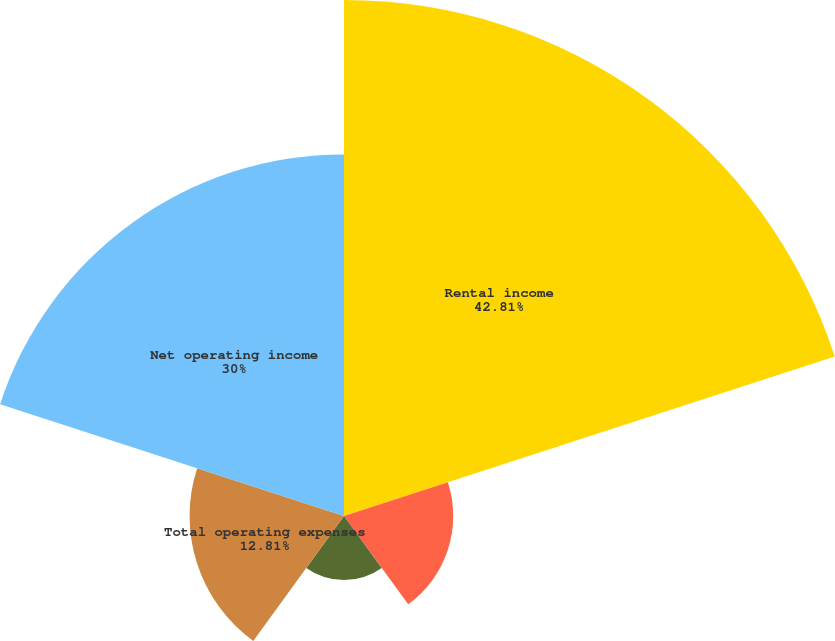Convert chart to OTSL. <chart><loc_0><loc_0><loc_500><loc_500><pie_chart><fcel>Rental income<fcel>Property and maintenance<fcel>Real estate taxes and<fcel>Total operating expenses<fcel>Net operating income<nl><fcel>42.81%<fcel>9.06%<fcel>5.32%<fcel>12.81%<fcel>30.0%<nl></chart> 